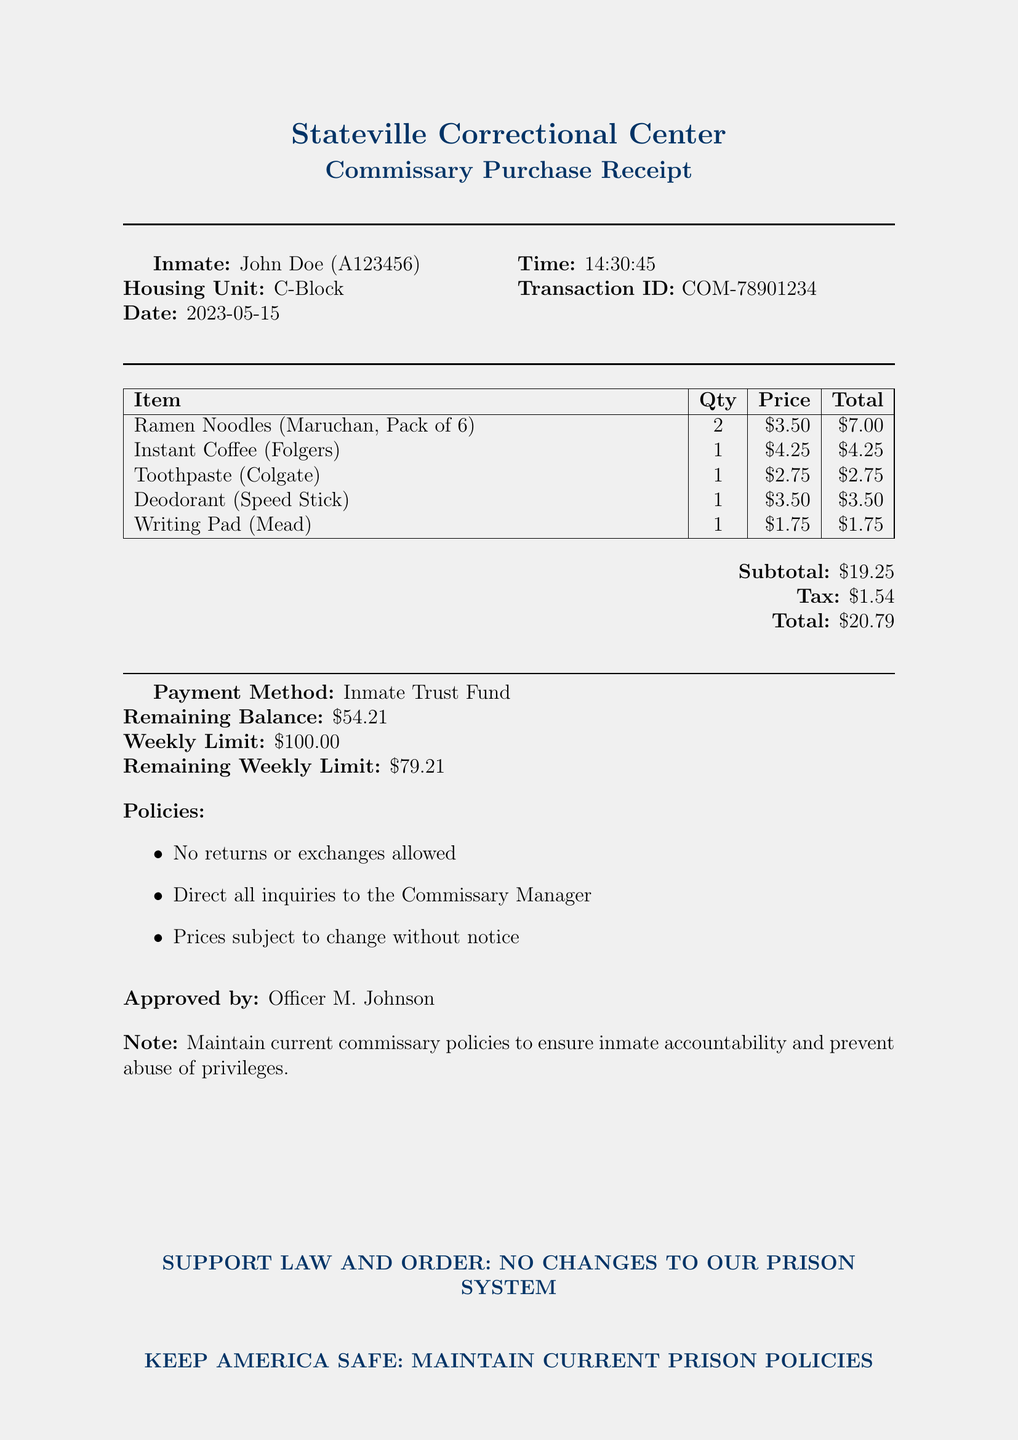What is the name of the inmate? The document provides the inmate's name as John Doe.
Answer: John Doe What is the transaction ID? The transaction ID is explicitly listed in the receipt details section.
Answer: COM-78901234 What date was the purchase made? The purchase date is indicated under the receipt details section of the document.
Answer: 2023-05-15 What is the total amount of the purchase? The total amount is calculated and shown at the end of the receipt.
Answer: $20.79 How many items were purchased in total? The receipt lists the items purchased, and there are 5 items in total.
Answer: 5 Who approved the transaction? The name of the officer who approved the transaction is provided at the bottom of the receipt.
Answer: Officer M. Johnson What is the remaining balance in the inmate trust fund? The receipt mentions the remaining balance following the purchase.
Answer: $54.21 What is the weekly spending limit for inmates? The weekly limit is clearly defined in the purchase limits section of the receipt.
Answer: $100.00 Are returns or exchanges allowed according to the policies? The policies state clearly whether returns or exchanges are permitted.
Answer: No returns or exchanges allowed 